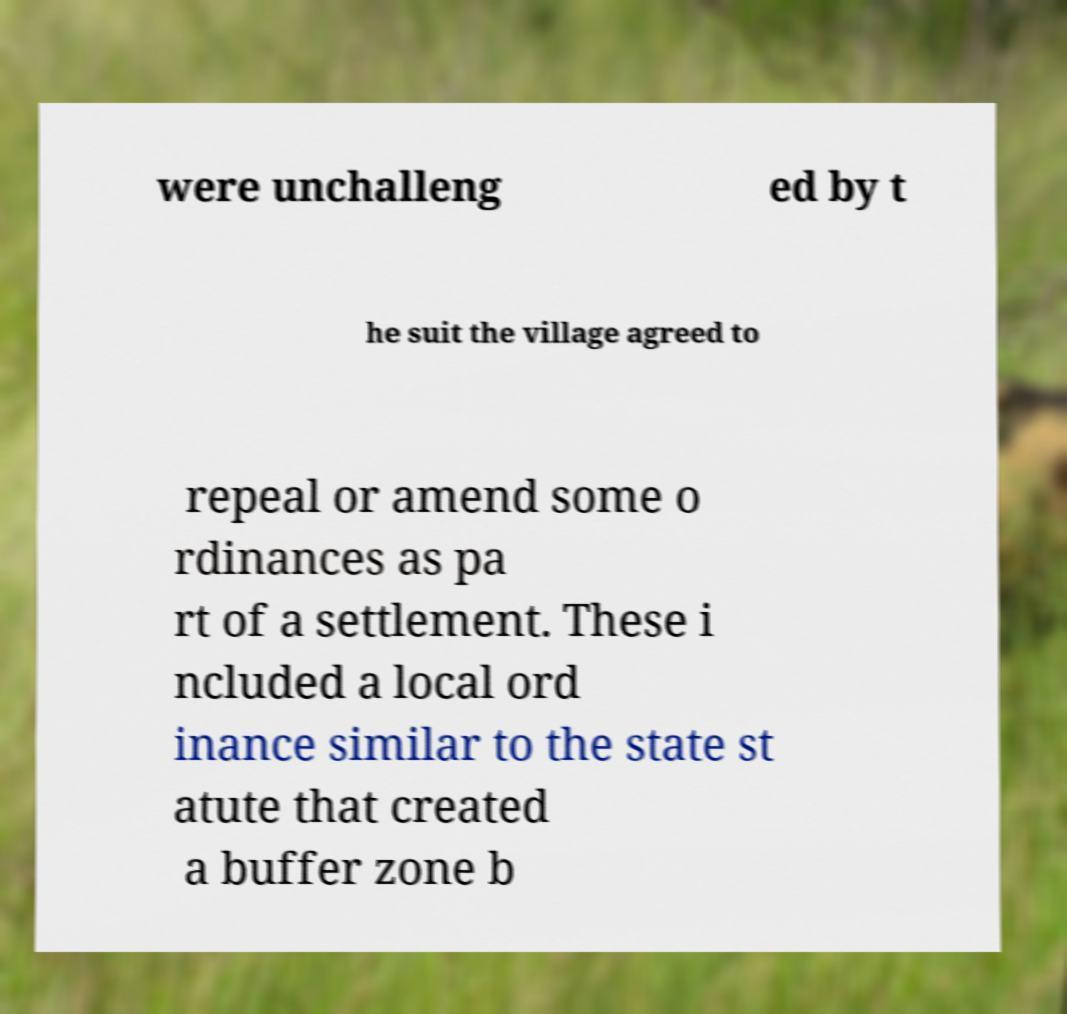I need the written content from this picture converted into text. Can you do that? were unchalleng ed by t he suit the village agreed to repeal or amend some o rdinances as pa rt of a settlement. These i ncluded a local ord inance similar to the state st atute that created a buffer zone b 